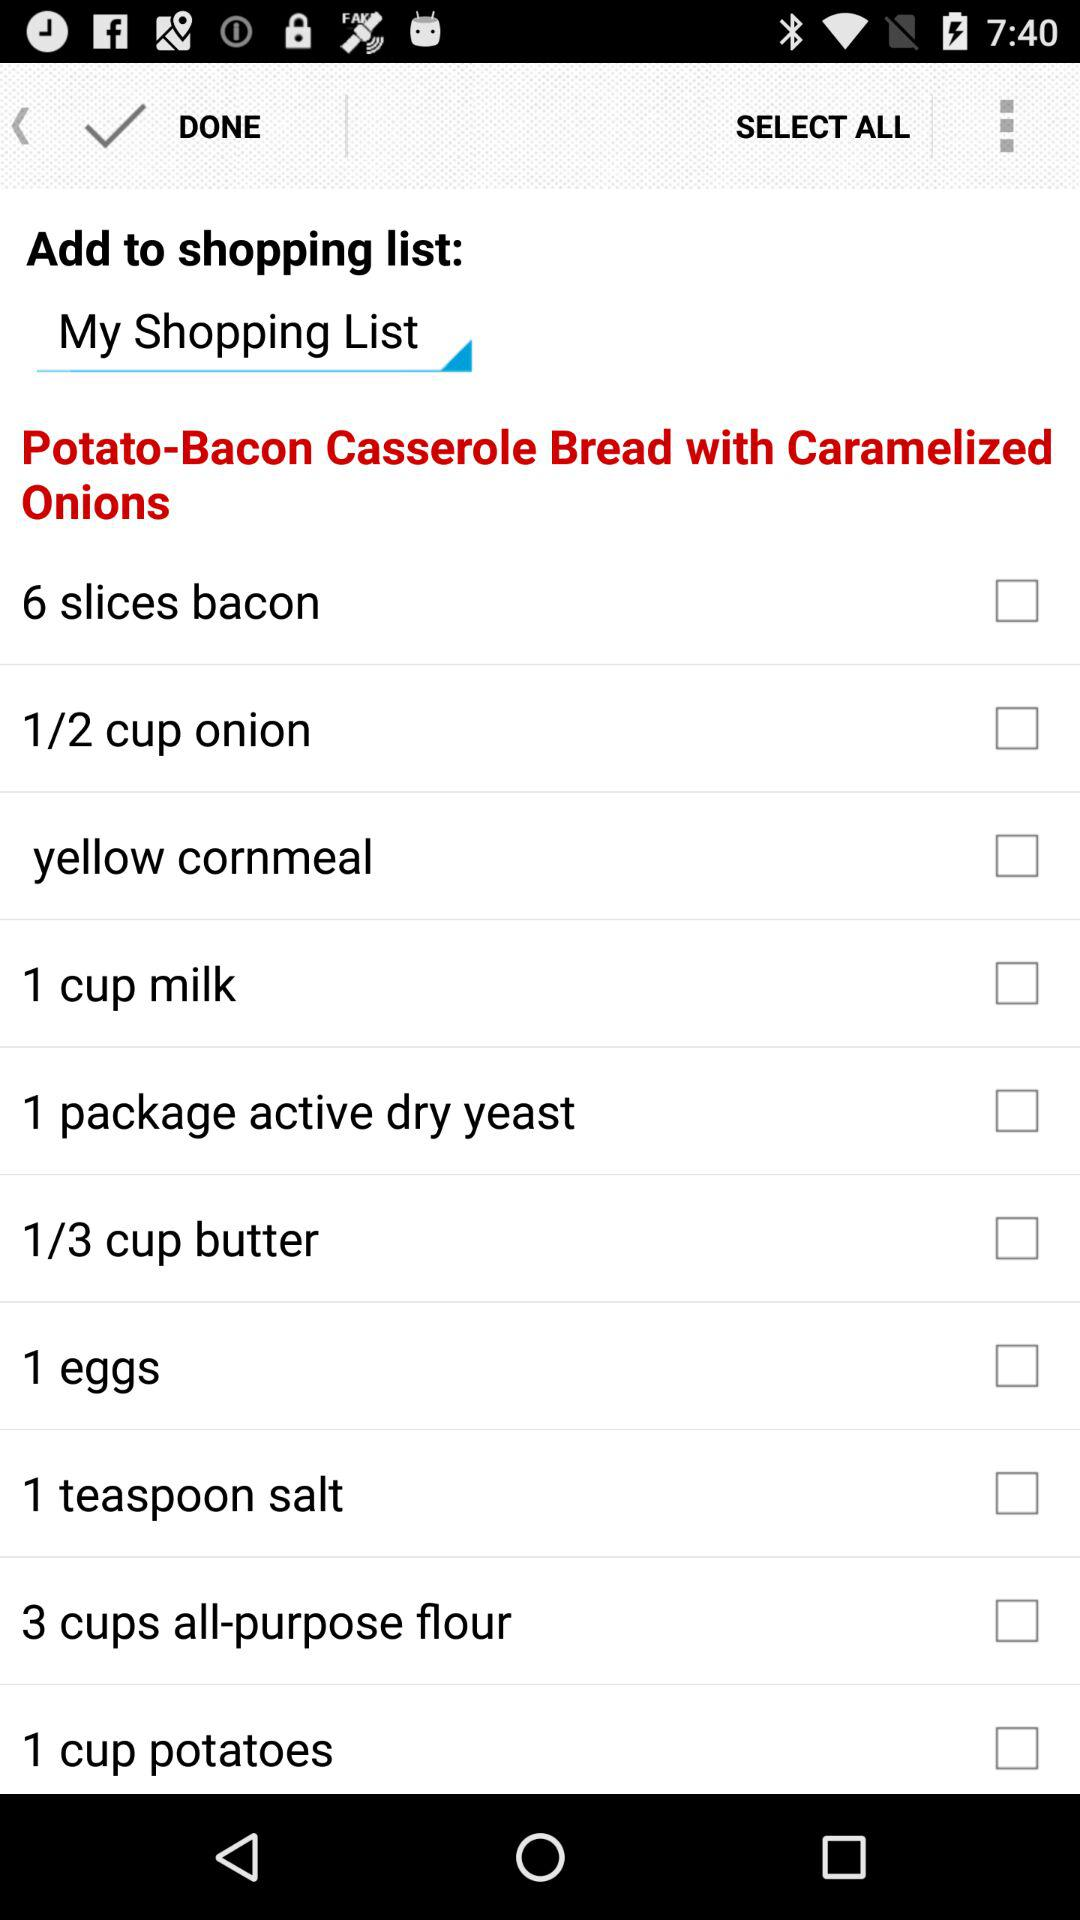How many eggs are required? There is 1 egg required. 